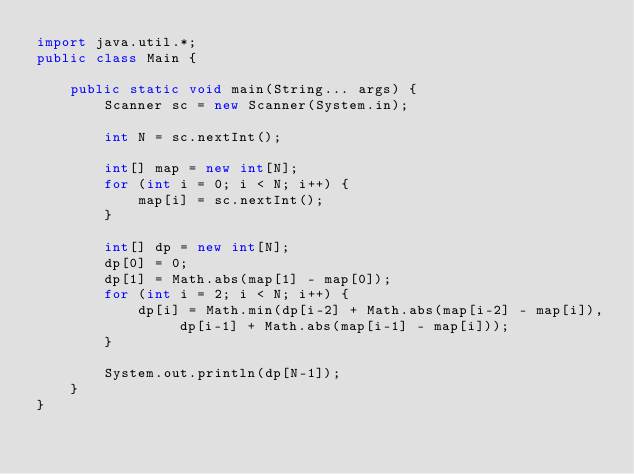<code> <loc_0><loc_0><loc_500><loc_500><_Java_>import java.util.*;
public class Main {
	
	public static void main(String... args) {
		Scanner sc = new Scanner(System.in);
		
		int N = sc.nextInt();
		
		int[] map = new int[N];
		for (int i = 0; i < N; i++) {
			map[i] = sc.nextInt();
		}
		
		int[] dp = new int[N];
		dp[0] = 0;
		dp[1] = Math.abs(map[1] - map[0]);
		for (int i = 2; i < N; i++) {
			dp[i] = Math.min(dp[i-2] + Math.abs(map[i-2] - map[i]), dp[i-1] + Math.abs(map[i-1] - map[i]));
		}
		
		System.out.println(dp[N-1]);
	}
}

</code> 